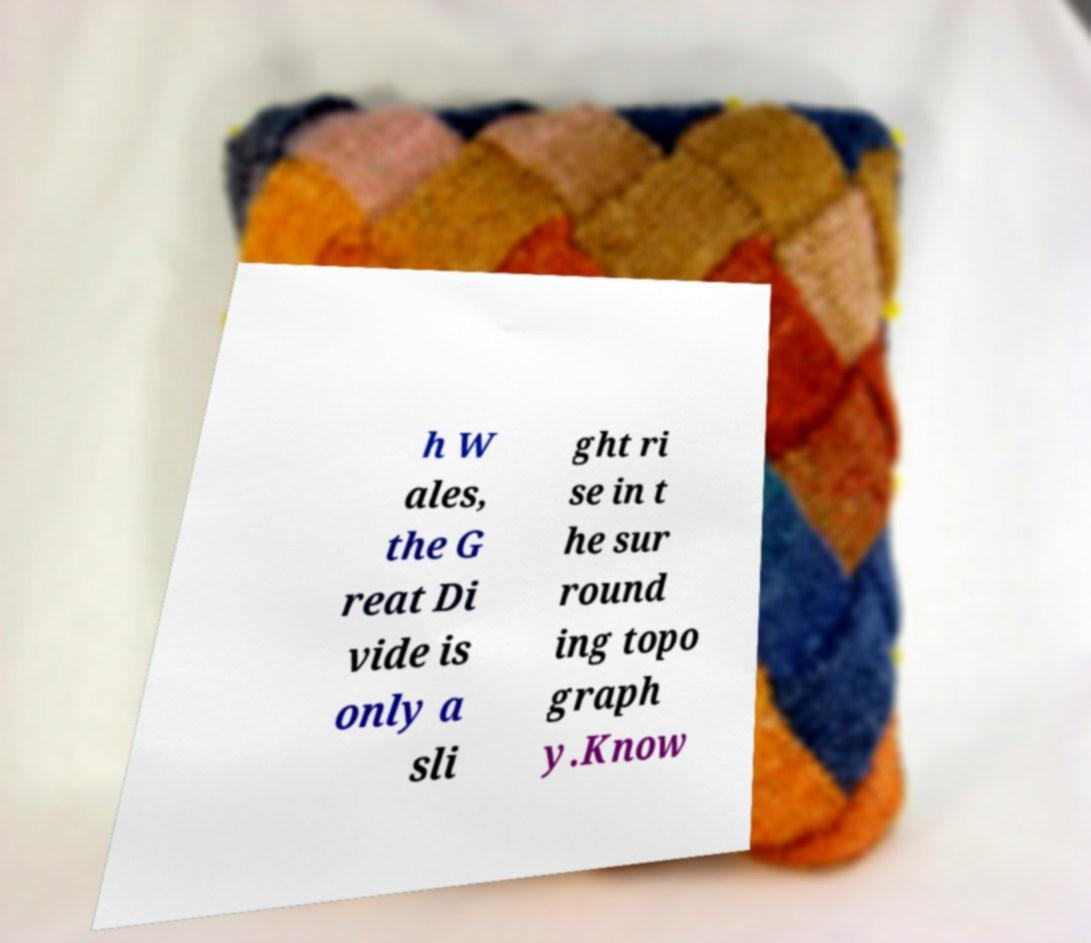What messages or text are displayed in this image? I need them in a readable, typed format. h W ales, the G reat Di vide is only a sli ght ri se in t he sur round ing topo graph y.Know 